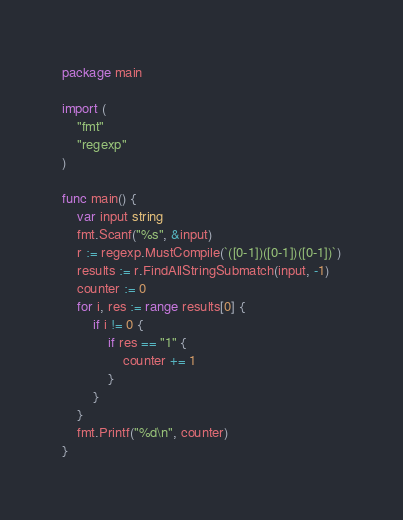Convert code to text. <code><loc_0><loc_0><loc_500><loc_500><_Go_>package main

import (
	"fmt"
	"regexp"
)

func main() {
	var input string
	fmt.Scanf("%s", &input)
	r := regexp.MustCompile(`([0-1])([0-1])([0-1])`)
	results := r.FindAllStringSubmatch(input, -1)
	counter := 0
	for i, res := range results[0] {
		if i != 0 {
			if res == "1" {
				counter += 1
			}
		}
	}
	fmt.Printf("%d\n", counter)
}</code> 